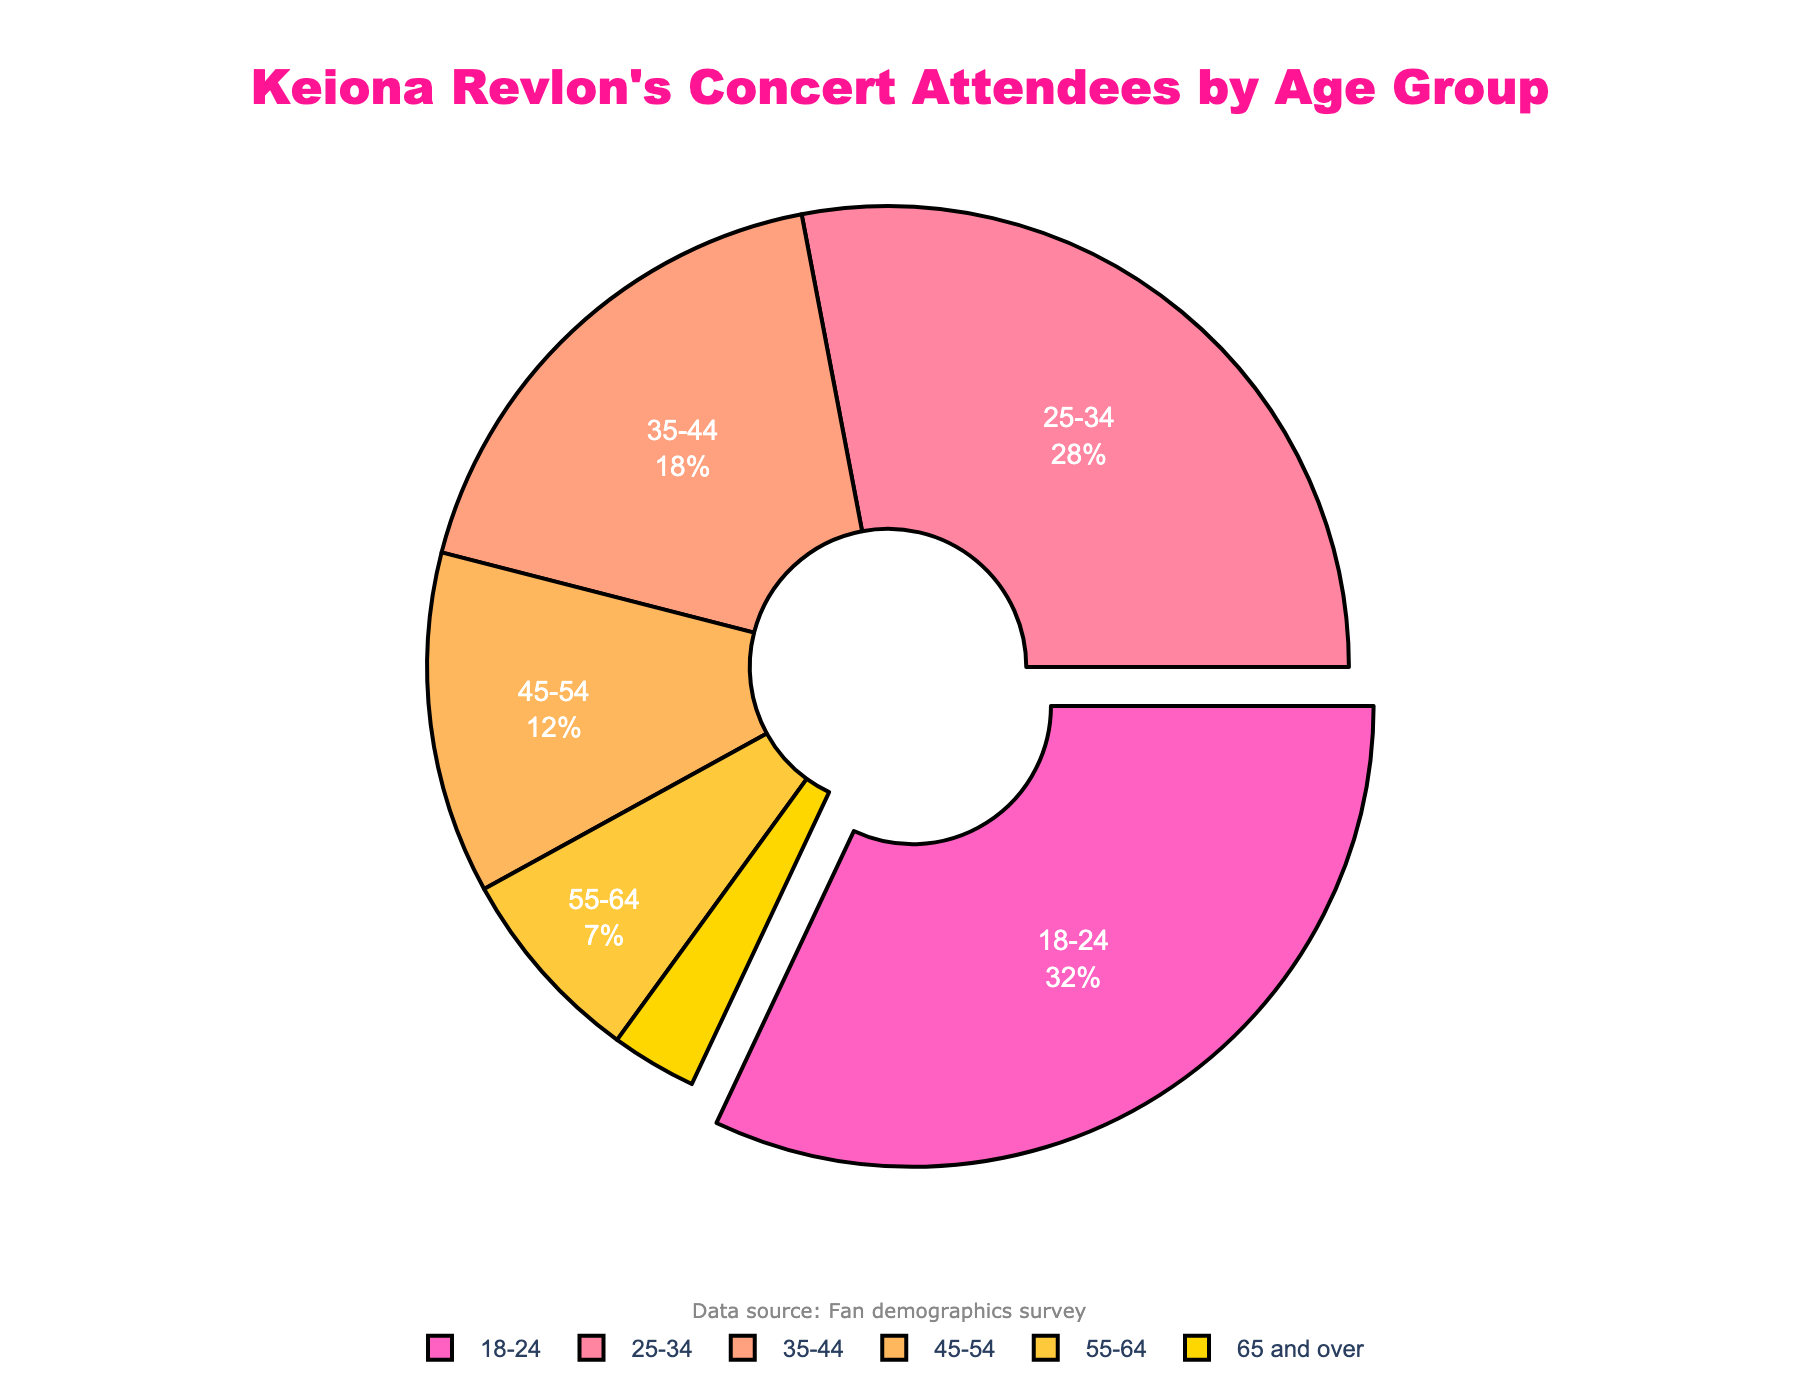What percentage of the concert attendees are between the ages of 18 and 34? To find the percentage of attendees between the ages of 18 and 34, add the percentages of the 18-24 and 25-34 age groups: 32% + 28% = 60%.
Answer: 60% Which age group has the smallest percentage of attendees? Look for the age group with the smallest value in the dataset. The '65 and over' group has a percentage of 3%, which is the smallest.
Answer: 65 and over Are there more attendees in the 35-44 age group compared to the 45-54 age group? Compare the percentages of the 35-44 and 45-54 age groups. The 35-44 age group has 18%, while the 45-54 age group has 12%. Since 18% is greater than 12%, the 35-44 age group has more attendees.
Answer: Yes How much larger is the percentage of attendees aged 18-24 compared to those aged 25-34? Subtract the percentage of the 25-34 age group from the 18-24 age group. 32% - 28% = 4%.
Answer: 4% If this event had exactly 1,000 attendees, how many of them would be between the ages of 55 and over? Add the percentages for the 55-64 and 65 and over groups: 7% + 3% = 10%. Multiply this by 1,000: 0.10 * 1000 = 100 attendees.
Answer: 100 What color represents the age group 45-54 in the pie chart? Identify the color used for the 45-54 age group segment in the pie chart, which is visually distinct from other segments. It is represented by the color with the third largest percentage after 18-24 and 25-34 age groups in the custom color palette used. The color is '#FFB75E' which corresponds to the shade of orange.
Answer: Orange How much larger is the percentage of the largest age group compared to the smallest age group? Subtract the percentage of the 65 and over age group (smallest at 3%) from the 18-24 age group (largest at 32%): 32% - 3% = 29%.
Answer: 29% 